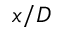<formula> <loc_0><loc_0><loc_500><loc_500>x / D</formula> 